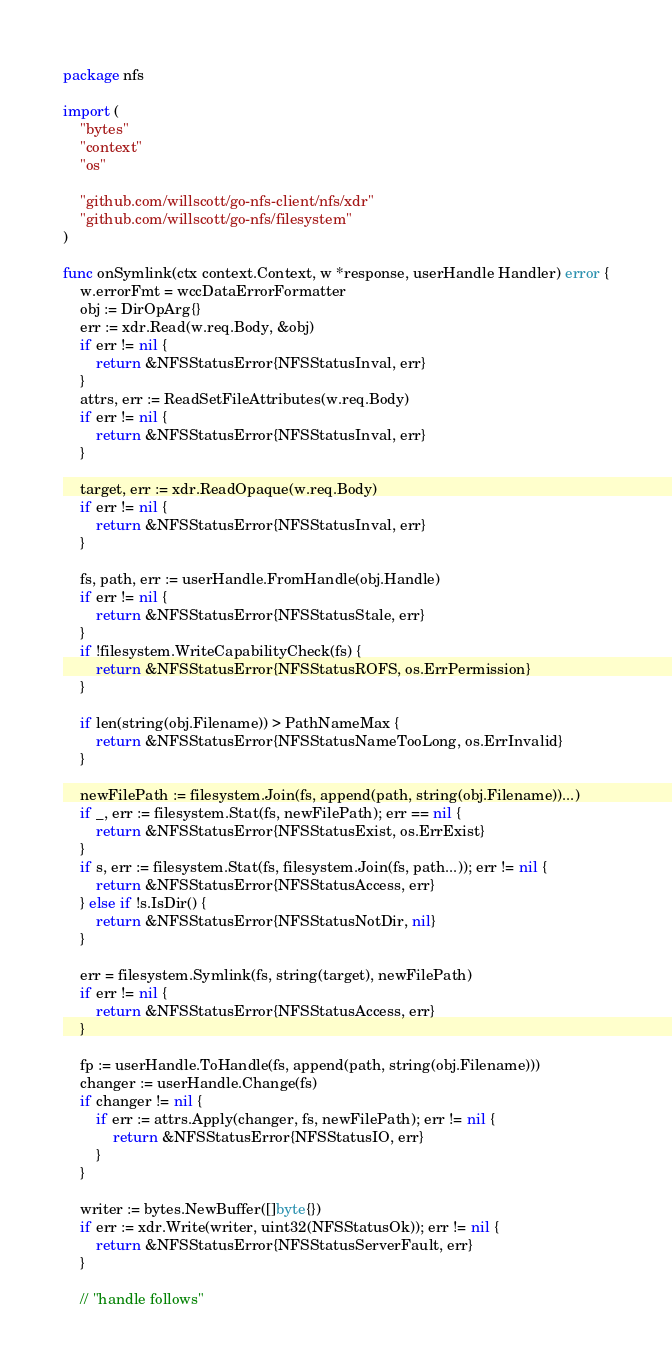Convert code to text. <code><loc_0><loc_0><loc_500><loc_500><_Go_>package nfs

import (
	"bytes"
	"context"
	"os"

	"github.com/willscott/go-nfs-client/nfs/xdr"
	"github.com/willscott/go-nfs/filesystem"
)

func onSymlink(ctx context.Context, w *response, userHandle Handler) error {
	w.errorFmt = wccDataErrorFormatter
	obj := DirOpArg{}
	err := xdr.Read(w.req.Body, &obj)
	if err != nil {
		return &NFSStatusError{NFSStatusInval, err}
	}
	attrs, err := ReadSetFileAttributes(w.req.Body)
	if err != nil {
		return &NFSStatusError{NFSStatusInval, err}
	}

	target, err := xdr.ReadOpaque(w.req.Body)
	if err != nil {
		return &NFSStatusError{NFSStatusInval, err}
	}

	fs, path, err := userHandle.FromHandle(obj.Handle)
	if err != nil {
		return &NFSStatusError{NFSStatusStale, err}
	}
	if !filesystem.WriteCapabilityCheck(fs) {
		return &NFSStatusError{NFSStatusROFS, os.ErrPermission}
	}

	if len(string(obj.Filename)) > PathNameMax {
		return &NFSStatusError{NFSStatusNameTooLong, os.ErrInvalid}
	}

	newFilePath := filesystem.Join(fs, append(path, string(obj.Filename))...)
	if _, err := filesystem.Stat(fs, newFilePath); err == nil {
		return &NFSStatusError{NFSStatusExist, os.ErrExist}
	}
	if s, err := filesystem.Stat(fs, filesystem.Join(fs, path...)); err != nil {
		return &NFSStatusError{NFSStatusAccess, err}
	} else if !s.IsDir() {
		return &NFSStatusError{NFSStatusNotDir, nil}
	}

	err = filesystem.Symlink(fs, string(target), newFilePath)
	if err != nil {
		return &NFSStatusError{NFSStatusAccess, err}
	}

	fp := userHandle.ToHandle(fs, append(path, string(obj.Filename)))
	changer := userHandle.Change(fs)
	if changer != nil {
		if err := attrs.Apply(changer, fs, newFilePath); err != nil {
			return &NFSStatusError{NFSStatusIO, err}
		}
	}

	writer := bytes.NewBuffer([]byte{})
	if err := xdr.Write(writer, uint32(NFSStatusOk)); err != nil {
		return &NFSStatusError{NFSStatusServerFault, err}
	}

	// "handle follows"</code> 